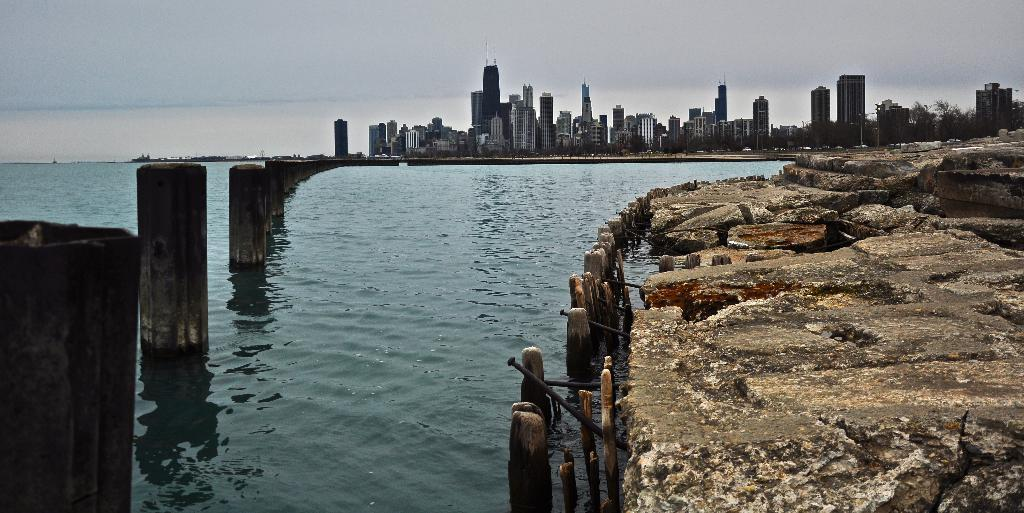What is the primary element visible in the image? There is water in the image. What structures can be seen in the image? There are poles and buildings in the image. What type of natural feature is present in the image? There are rocks in the image. What is visible in the background of the image? The sky is visible in the image. What type of vegetation is on the right side of the image? There are trees on the right side of the image. What flavor of grass can be seen growing near the water in the image? There is no grass present in the image, and therefore no flavor can be determined. 